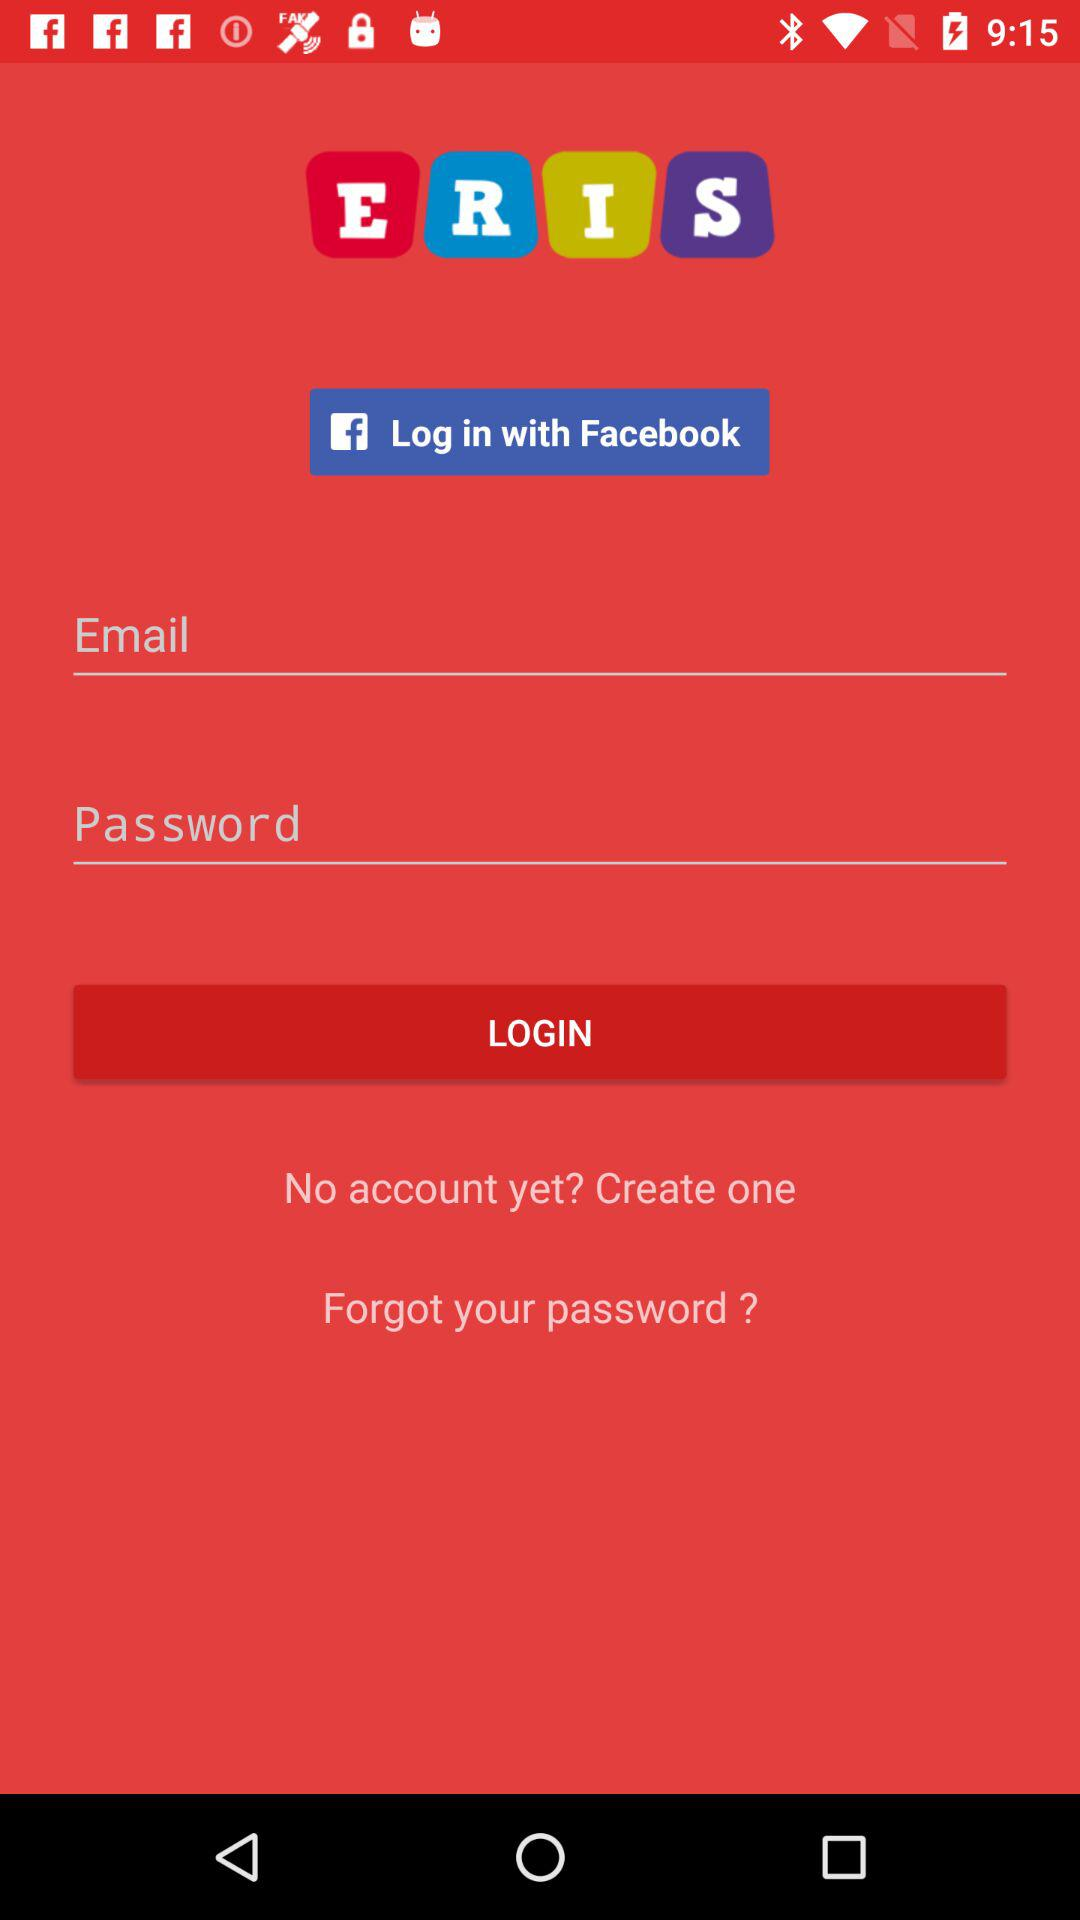What is the name of the application? The name of the application is "ERIS". 